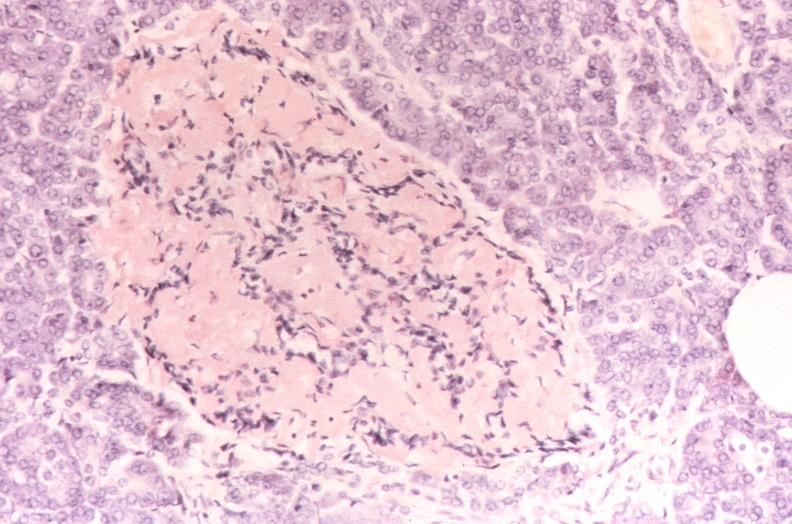does this image show pancreatic islet, amyloidosis diabetes mellitus, congo red stain?
Answer the question using a single word or phrase. Yes 